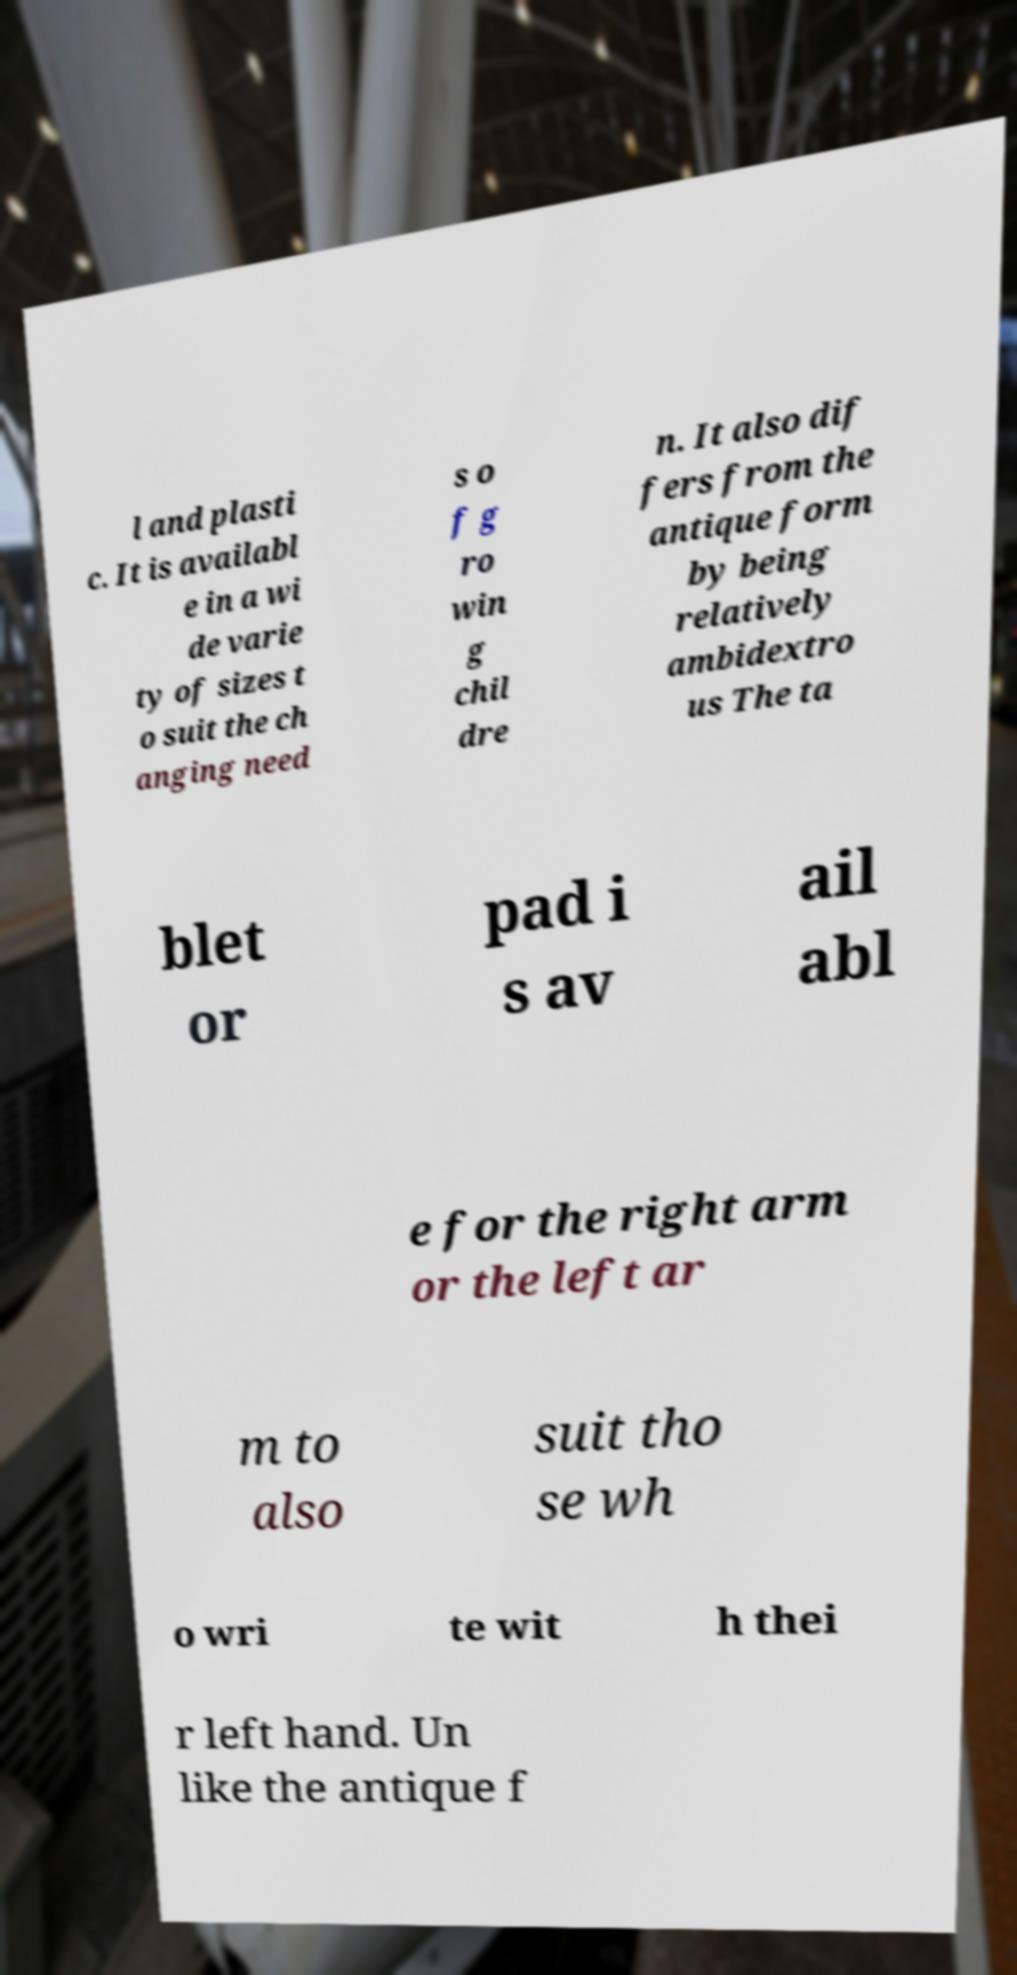What messages or text are displayed in this image? I need them in a readable, typed format. l and plasti c. It is availabl e in a wi de varie ty of sizes t o suit the ch anging need s o f g ro win g chil dre n. It also dif fers from the antique form by being relatively ambidextro us The ta blet or pad i s av ail abl e for the right arm or the left ar m to also suit tho se wh o wri te wit h thei r left hand. Un like the antique f 